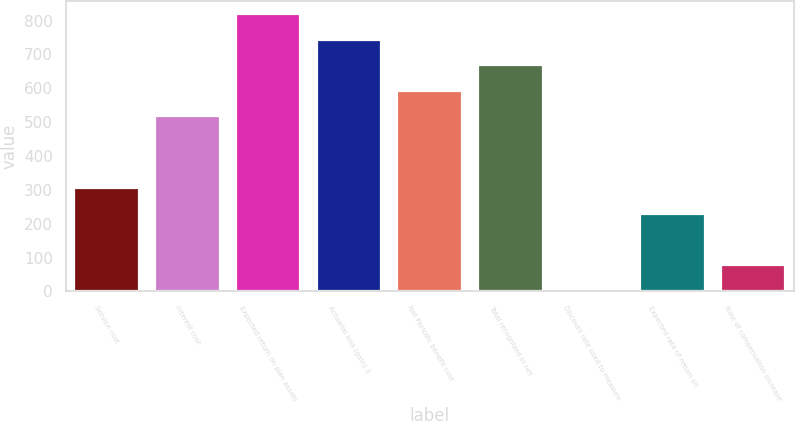<chart> <loc_0><loc_0><loc_500><loc_500><bar_chart><fcel>Service cost<fcel>Interest cost<fcel>Expected return on plan assets<fcel>Actuarial loss (gain) 3<fcel>Net Periodic benefit cost<fcel>Total recognized in net<fcel>Discount rate used to measure<fcel>Expected rate of return on<fcel>Rate of compensation increase<nl><fcel>304.84<fcel>517<fcel>818.44<fcel>743.08<fcel>592.36<fcel>667.72<fcel>3.4<fcel>229.48<fcel>78.76<nl></chart> 